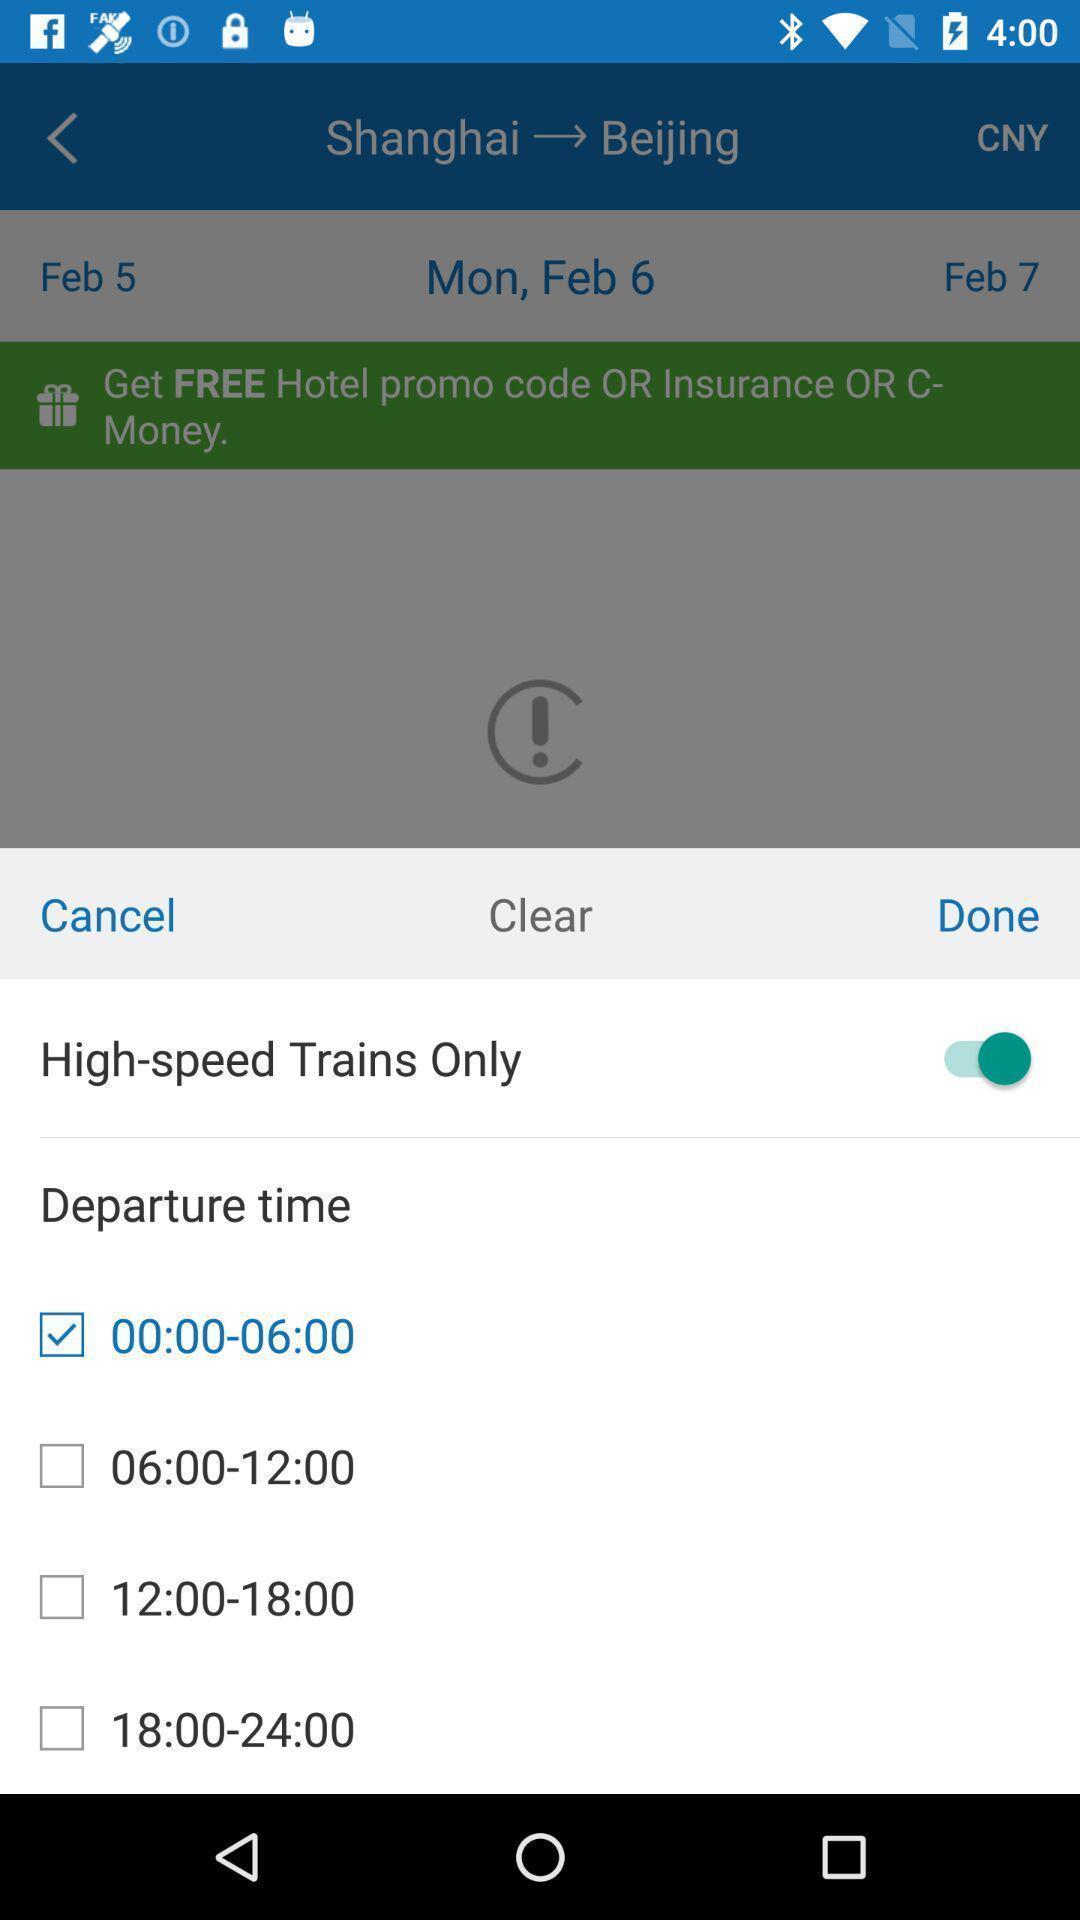Summarize the information in this screenshot. Push up notification displayed departure time to be select. 